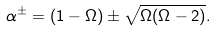Convert formula to latex. <formula><loc_0><loc_0><loc_500><loc_500>\alpha ^ { \pm } = ( 1 - \Omega ) \pm \sqrt { \Omega ( \Omega - 2 ) } .</formula> 